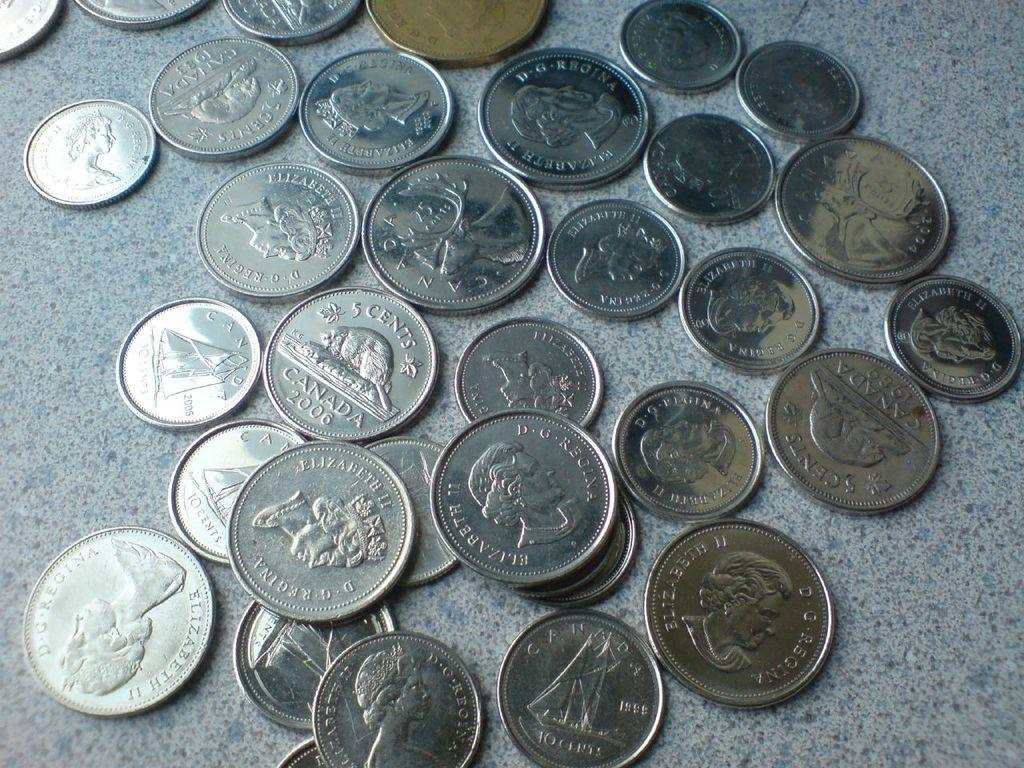<image>
Provide a brief description of the given image. Many silver coins on a table showing Elizabeth. 